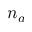<formula> <loc_0><loc_0><loc_500><loc_500>n _ { a }</formula> 